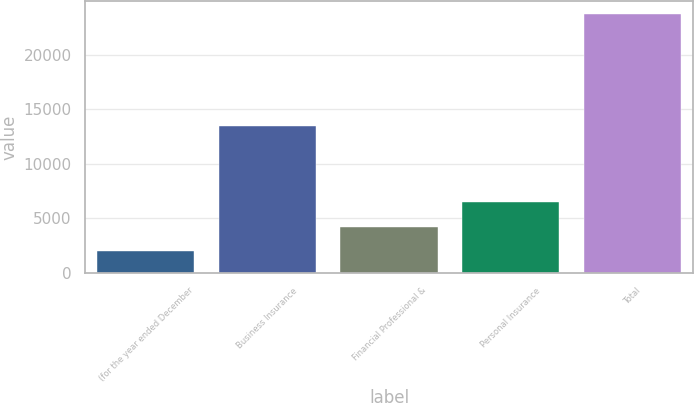Convert chart to OTSL. <chart><loc_0><loc_0><loc_500><loc_500><bar_chart><fcel>(for the year ended December<fcel>Business Insurance<fcel>Financial Professional &<fcel>Personal Insurance<fcel>Total<nl><fcel>2005<fcel>13453<fcel>4178.1<fcel>6474<fcel>23736<nl></chart> 